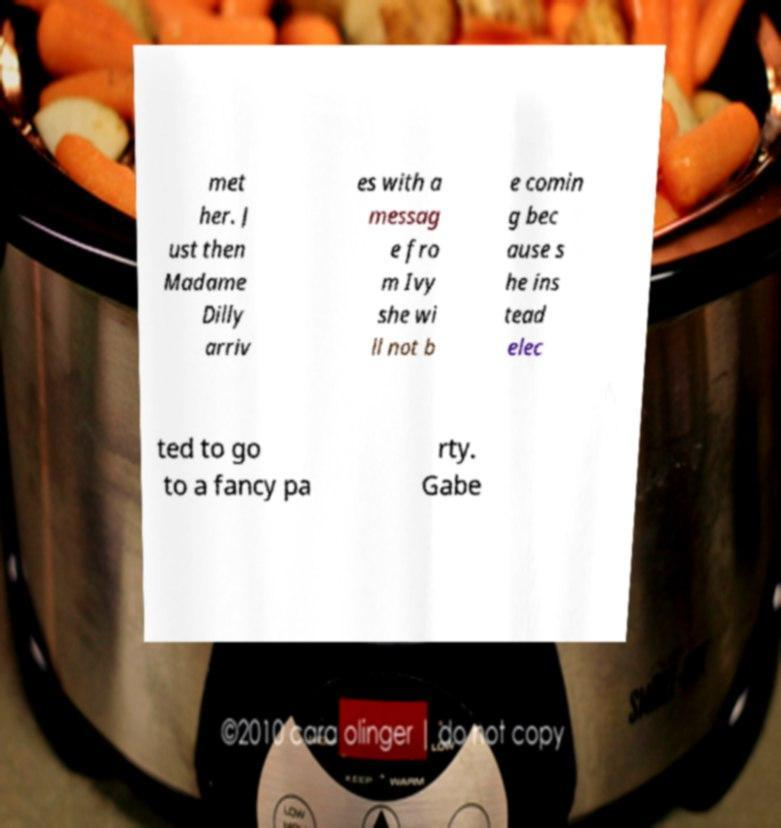Can you accurately transcribe the text from the provided image for me? met her. J ust then Madame Dilly arriv es with a messag e fro m Ivy she wi ll not b e comin g bec ause s he ins tead elec ted to go to a fancy pa rty. Gabe 